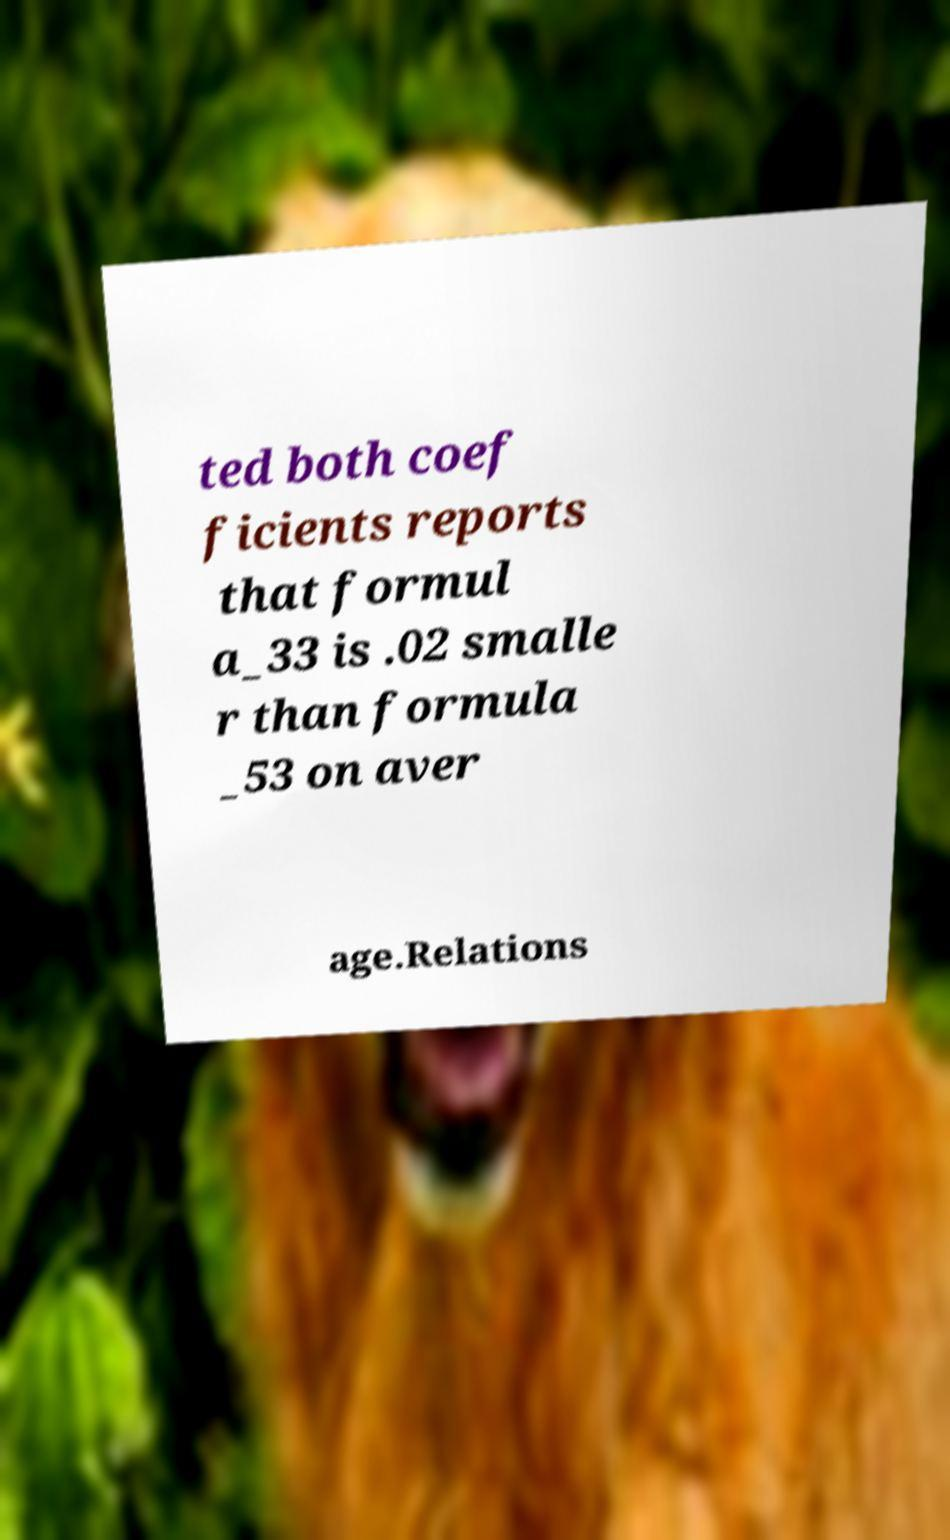I need the written content from this picture converted into text. Can you do that? ted both coef ficients reports that formul a_33 is .02 smalle r than formula _53 on aver age.Relations 